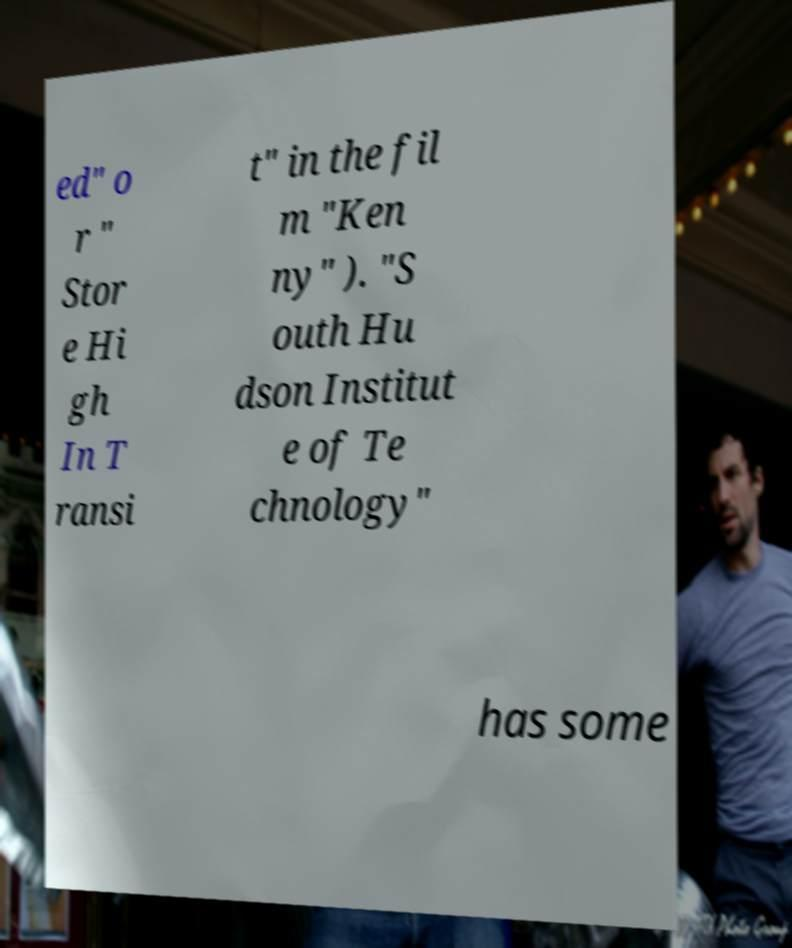What messages or text are displayed in this image? I need them in a readable, typed format. ed" o r " Stor e Hi gh In T ransi t" in the fil m "Ken ny" ). "S outh Hu dson Institut e of Te chnology" has some 